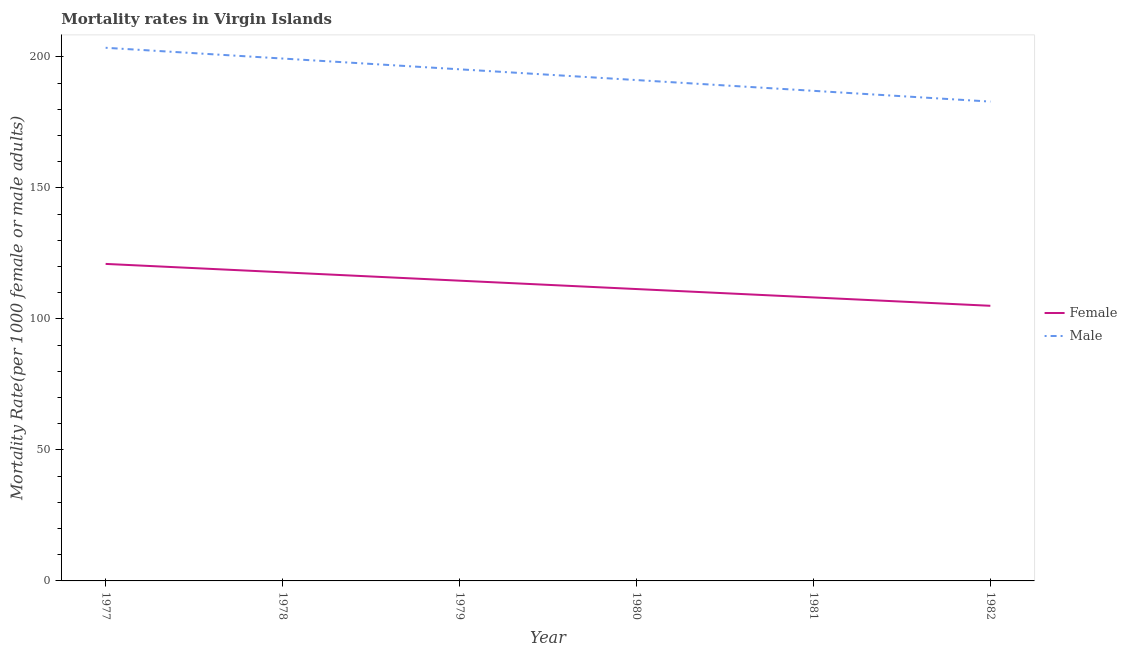Does the line corresponding to male mortality rate intersect with the line corresponding to female mortality rate?
Your answer should be compact. No. Is the number of lines equal to the number of legend labels?
Your answer should be very brief. Yes. What is the female mortality rate in 1980?
Your answer should be very brief. 111.38. Across all years, what is the maximum male mortality rate?
Make the answer very short. 203.45. Across all years, what is the minimum male mortality rate?
Provide a succinct answer. 182.92. In which year was the male mortality rate minimum?
Your response must be concise. 1982. What is the total female mortality rate in the graph?
Provide a short and direct response. 677.89. What is the difference between the male mortality rate in 1981 and that in 1982?
Provide a succinct answer. 4.11. What is the difference between the male mortality rate in 1980 and the female mortality rate in 1978?
Make the answer very short. 73.36. What is the average female mortality rate per year?
Provide a short and direct response. 112.98. In the year 1982, what is the difference between the male mortality rate and female mortality rate?
Keep it short and to the point. 77.93. In how many years, is the female mortality rate greater than 160?
Your response must be concise. 0. What is the ratio of the female mortality rate in 1980 to that in 1981?
Your answer should be compact. 1.03. What is the difference between the highest and the second highest female mortality rate?
Offer a very short reply. 3.2. What is the difference between the highest and the lowest female mortality rate?
Make the answer very short. 15.98. In how many years, is the male mortality rate greater than the average male mortality rate taken over all years?
Your response must be concise. 3. Is the sum of the female mortality rate in 1979 and 1981 greater than the maximum male mortality rate across all years?
Offer a terse response. Yes. Does the male mortality rate monotonically increase over the years?
Your response must be concise. No. Is the female mortality rate strictly greater than the male mortality rate over the years?
Offer a very short reply. No. How many lines are there?
Offer a terse response. 2. Does the graph contain any zero values?
Ensure brevity in your answer.  No. Does the graph contain grids?
Your response must be concise. No. Where does the legend appear in the graph?
Make the answer very short. Center right. What is the title of the graph?
Your response must be concise. Mortality rates in Virgin Islands. What is the label or title of the Y-axis?
Your answer should be very brief. Mortality Rate(per 1000 female or male adults). What is the Mortality Rate(per 1000 female or male adults) of Female in 1977?
Ensure brevity in your answer.  120.97. What is the Mortality Rate(per 1000 female or male adults) in Male in 1977?
Give a very brief answer. 203.45. What is the Mortality Rate(per 1000 female or male adults) of Female in 1978?
Make the answer very short. 117.78. What is the Mortality Rate(per 1000 female or male adults) of Male in 1978?
Keep it short and to the point. 199.35. What is the Mortality Rate(per 1000 female or male adults) of Female in 1979?
Make the answer very short. 114.58. What is the Mortality Rate(per 1000 female or male adults) of Male in 1979?
Offer a very short reply. 195.24. What is the Mortality Rate(per 1000 female or male adults) in Female in 1980?
Offer a very short reply. 111.38. What is the Mortality Rate(per 1000 female or male adults) of Male in 1980?
Ensure brevity in your answer.  191.13. What is the Mortality Rate(per 1000 female or male adults) of Female in 1981?
Ensure brevity in your answer.  108.19. What is the Mortality Rate(per 1000 female or male adults) of Male in 1981?
Offer a terse response. 187.03. What is the Mortality Rate(per 1000 female or male adults) of Female in 1982?
Your response must be concise. 104.99. What is the Mortality Rate(per 1000 female or male adults) of Male in 1982?
Keep it short and to the point. 182.92. Across all years, what is the maximum Mortality Rate(per 1000 female or male adults) in Female?
Keep it short and to the point. 120.97. Across all years, what is the maximum Mortality Rate(per 1000 female or male adults) of Male?
Offer a terse response. 203.45. Across all years, what is the minimum Mortality Rate(per 1000 female or male adults) of Female?
Provide a succinct answer. 104.99. Across all years, what is the minimum Mortality Rate(per 1000 female or male adults) in Male?
Your answer should be compact. 182.92. What is the total Mortality Rate(per 1000 female or male adults) of Female in the graph?
Provide a short and direct response. 677.89. What is the total Mortality Rate(per 1000 female or male adults) in Male in the graph?
Ensure brevity in your answer.  1159.12. What is the difference between the Mortality Rate(per 1000 female or male adults) in Female in 1977 and that in 1978?
Keep it short and to the point. 3.2. What is the difference between the Mortality Rate(per 1000 female or male adults) of Male in 1977 and that in 1978?
Your answer should be compact. 4.11. What is the difference between the Mortality Rate(per 1000 female or male adults) of Female in 1977 and that in 1979?
Your answer should be compact. 6.39. What is the difference between the Mortality Rate(per 1000 female or male adults) of Male in 1977 and that in 1979?
Offer a very short reply. 8.21. What is the difference between the Mortality Rate(per 1000 female or male adults) of Female in 1977 and that in 1980?
Make the answer very short. 9.59. What is the difference between the Mortality Rate(per 1000 female or male adults) of Male in 1977 and that in 1980?
Offer a very short reply. 12.32. What is the difference between the Mortality Rate(per 1000 female or male adults) in Female in 1977 and that in 1981?
Provide a succinct answer. 12.79. What is the difference between the Mortality Rate(per 1000 female or male adults) in Male in 1977 and that in 1981?
Offer a terse response. 16.43. What is the difference between the Mortality Rate(per 1000 female or male adults) in Female in 1977 and that in 1982?
Ensure brevity in your answer.  15.98. What is the difference between the Mortality Rate(per 1000 female or male adults) in Male in 1977 and that in 1982?
Your response must be concise. 20.54. What is the difference between the Mortality Rate(per 1000 female or male adults) in Female in 1978 and that in 1979?
Your answer should be compact. 3.2. What is the difference between the Mortality Rate(per 1000 female or male adults) in Male in 1978 and that in 1979?
Provide a succinct answer. 4.11. What is the difference between the Mortality Rate(per 1000 female or male adults) of Female in 1978 and that in 1980?
Your response must be concise. 6.39. What is the difference between the Mortality Rate(per 1000 female or male adults) of Male in 1978 and that in 1980?
Your answer should be compact. 8.21. What is the difference between the Mortality Rate(per 1000 female or male adults) in Female in 1978 and that in 1981?
Offer a terse response. 9.59. What is the difference between the Mortality Rate(per 1000 female or male adults) of Male in 1978 and that in 1981?
Offer a very short reply. 12.32. What is the difference between the Mortality Rate(per 1000 female or male adults) of Female in 1978 and that in 1982?
Make the answer very short. 12.79. What is the difference between the Mortality Rate(per 1000 female or male adults) of Male in 1978 and that in 1982?
Provide a succinct answer. 16.43. What is the difference between the Mortality Rate(per 1000 female or male adults) in Female in 1979 and that in 1980?
Provide a succinct answer. 3.2. What is the difference between the Mortality Rate(per 1000 female or male adults) in Male in 1979 and that in 1980?
Your answer should be compact. 4.11. What is the difference between the Mortality Rate(per 1000 female or male adults) in Female in 1979 and that in 1981?
Provide a short and direct response. 6.39. What is the difference between the Mortality Rate(per 1000 female or male adults) of Male in 1979 and that in 1981?
Keep it short and to the point. 8.21. What is the difference between the Mortality Rate(per 1000 female or male adults) in Female in 1979 and that in 1982?
Keep it short and to the point. 9.59. What is the difference between the Mortality Rate(per 1000 female or male adults) in Male in 1979 and that in 1982?
Your answer should be very brief. 12.32. What is the difference between the Mortality Rate(per 1000 female or male adults) of Female in 1980 and that in 1981?
Offer a very short reply. 3.2. What is the difference between the Mortality Rate(per 1000 female or male adults) in Male in 1980 and that in 1981?
Provide a succinct answer. 4.11. What is the difference between the Mortality Rate(per 1000 female or male adults) in Female in 1980 and that in 1982?
Make the answer very short. 6.39. What is the difference between the Mortality Rate(per 1000 female or male adults) of Male in 1980 and that in 1982?
Give a very brief answer. 8.21. What is the difference between the Mortality Rate(per 1000 female or male adults) in Female in 1981 and that in 1982?
Provide a succinct answer. 3.2. What is the difference between the Mortality Rate(per 1000 female or male adults) of Male in 1981 and that in 1982?
Your answer should be very brief. 4.11. What is the difference between the Mortality Rate(per 1000 female or male adults) in Female in 1977 and the Mortality Rate(per 1000 female or male adults) in Male in 1978?
Give a very brief answer. -78.37. What is the difference between the Mortality Rate(per 1000 female or male adults) of Female in 1977 and the Mortality Rate(per 1000 female or male adults) of Male in 1979?
Keep it short and to the point. -74.27. What is the difference between the Mortality Rate(per 1000 female or male adults) in Female in 1977 and the Mortality Rate(per 1000 female or male adults) in Male in 1980?
Make the answer very short. -70.16. What is the difference between the Mortality Rate(per 1000 female or male adults) in Female in 1977 and the Mortality Rate(per 1000 female or male adults) in Male in 1981?
Give a very brief answer. -66.05. What is the difference between the Mortality Rate(per 1000 female or male adults) in Female in 1977 and the Mortality Rate(per 1000 female or male adults) in Male in 1982?
Your answer should be very brief. -61.95. What is the difference between the Mortality Rate(per 1000 female or male adults) of Female in 1978 and the Mortality Rate(per 1000 female or male adults) of Male in 1979?
Give a very brief answer. -77.46. What is the difference between the Mortality Rate(per 1000 female or male adults) in Female in 1978 and the Mortality Rate(per 1000 female or male adults) in Male in 1980?
Your answer should be compact. -73.36. What is the difference between the Mortality Rate(per 1000 female or male adults) of Female in 1978 and the Mortality Rate(per 1000 female or male adults) of Male in 1981?
Provide a succinct answer. -69.25. What is the difference between the Mortality Rate(per 1000 female or male adults) in Female in 1978 and the Mortality Rate(per 1000 female or male adults) in Male in 1982?
Offer a terse response. -65.14. What is the difference between the Mortality Rate(per 1000 female or male adults) in Female in 1979 and the Mortality Rate(per 1000 female or male adults) in Male in 1980?
Keep it short and to the point. -76.55. What is the difference between the Mortality Rate(per 1000 female or male adults) of Female in 1979 and the Mortality Rate(per 1000 female or male adults) of Male in 1981?
Offer a very short reply. -72.45. What is the difference between the Mortality Rate(per 1000 female or male adults) of Female in 1979 and the Mortality Rate(per 1000 female or male adults) of Male in 1982?
Your answer should be compact. -68.34. What is the difference between the Mortality Rate(per 1000 female or male adults) in Female in 1980 and the Mortality Rate(per 1000 female or male adults) in Male in 1981?
Keep it short and to the point. -75.64. What is the difference between the Mortality Rate(per 1000 female or male adults) of Female in 1980 and the Mortality Rate(per 1000 female or male adults) of Male in 1982?
Give a very brief answer. -71.54. What is the difference between the Mortality Rate(per 1000 female or male adults) in Female in 1981 and the Mortality Rate(per 1000 female or male adults) in Male in 1982?
Provide a succinct answer. -74.73. What is the average Mortality Rate(per 1000 female or male adults) of Female per year?
Your answer should be very brief. 112.98. What is the average Mortality Rate(per 1000 female or male adults) of Male per year?
Offer a terse response. 193.19. In the year 1977, what is the difference between the Mortality Rate(per 1000 female or male adults) in Female and Mortality Rate(per 1000 female or male adults) in Male?
Keep it short and to the point. -82.48. In the year 1978, what is the difference between the Mortality Rate(per 1000 female or male adults) in Female and Mortality Rate(per 1000 female or male adults) in Male?
Provide a short and direct response. -81.57. In the year 1979, what is the difference between the Mortality Rate(per 1000 female or male adults) of Female and Mortality Rate(per 1000 female or male adults) of Male?
Offer a terse response. -80.66. In the year 1980, what is the difference between the Mortality Rate(per 1000 female or male adults) in Female and Mortality Rate(per 1000 female or male adults) in Male?
Ensure brevity in your answer.  -79.75. In the year 1981, what is the difference between the Mortality Rate(per 1000 female or male adults) in Female and Mortality Rate(per 1000 female or male adults) in Male?
Provide a short and direct response. -78.84. In the year 1982, what is the difference between the Mortality Rate(per 1000 female or male adults) of Female and Mortality Rate(per 1000 female or male adults) of Male?
Offer a terse response. -77.93. What is the ratio of the Mortality Rate(per 1000 female or male adults) in Female in 1977 to that in 1978?
Make the answer very short. 1.03. What is the ratio of the Mortality Rate(per 1000 female or male adults) of Male in 1977 to that in 1978?
Provide a short and direct response. 1.02. What is the ratio of the Mortality Rate(per 1000 female or male adults) in Female in 1977 to that in 1979?
Provide a succinct answer. 1.06. What is the ratio of the Mortality Rate(per 1000 female or male adults) of Male in 1977 to that in 1979?
Give a very brief answer. 1.04. What is the ratio of the Mortality Rate(per 1000 female or male adults) of Female in 1977 to that in 1980?
Your answer should be very brief. 1.09. What is the ratio of the Mortality Rate(per 1000 female or male adults) of Male in 1977 to that in 1980?
Ensure brevity in your answer.  1.06. What is the ratio of the Mortality Rate(per 1000 female or male adults) of Female in 1977 to that in 1981?
Offer a very short reply. 1.12. What is the ratio of the Mortality Rate(per 1000 female or male adults) in Male in 1977 to that in 1981?
Offer a very short reply. 1.09. What is the ratio of the Mortality Rate(per 1000 female or male adults) of Female in 1977 to that in 1982?
Provide a short and direct response. 1.15. What is the ratio of the Mortality Rate(per 1000 female or male adults) in Male in 1977 to that in 1982?
Make the answer very short. 1.11. What is the ratio of the Mortality Rate(per 1000 female or male adults) of Female in 1978 to that in 1979?
Give a very brief answer. 1.03. What is the ratio of the Mortality Rate(per 1000 female or male adults) in Male in 1978 to that in 1979?
Keep it short and to the point. 1.02. What is the ratio of the Mortality Rate(per 1000 female or male adults) of Female in 1978 to that in 1980?
Make the answer very short. 1.06. What is the ratio of the Mortality Rate(per 1000 female or male adults) in Male in 1978 to that in 1980?
Provide a short and direct response. 1.04. What is the ratio of the Mortality Rate(per 1000 female or male adults) in Female in 1978 to that in 1981?
Your response must be concise. 1.09. What is the ratio of the Mortality Rate(per 1000 female or male adults) in Male in 1978 to that in 1981?
Provide a short and direct response. 1.07. What is the ratio of the Mortality Rate(per 1000 female or male adults) of Female in 1978 to that in 1982?
Your response must be concise. 1.12. What is the ratio of the Mortality Rate(per 1000 female or male adults) in Male in 1978 to that in 1982?
Give a very brief answer. 1.09. What is the ratio of the Mortality Rate(per 1000 female or male adults) in Female in 1979 to that in 1980?
Your answer should be very brief. 1.03. What is the ratio of the Mortality Rate(per 1000 female or male adults) in Male in 1979 to that in 1980?
Your response must be concise. 1.02. What is the ratio of the Mortality Rate(per 1000 female or male adults) in Female in 1979 to that in 1981?
Give a very brief answer. 1.06. What is the ratio of the Mortality Rate(per 1000 female or male adults) in Male in 1979 to that in 1981?
Ensure brevity in your answer.  1.04. What is the ratio of the Mortality Rate(per 1000 female or male adults) of Female in 1979 to that in 1982?
Keep it short and to the point. 1.09. What is the ratio of the Mortality Rate(per 1000 female or male adults) in Male in 1979 to that in 1982?
Provide a short and direct response. 1.07. What is the ratio of the Mortality Rate(per 1000 female or male adults) of Female in 1980 to that in 1981?
Ensure brevity in your answer.  1.03. What is the ratio of the Mortality Rate(per 1000 female or male adults) of Female in 1980 to that in 1982?
Ensure brevity in your answer.  1.06. What is the ratio of the Mortality Rate(per 1000 female or male adults) in Male in 1980 to that in 1982?
Ensure brevity in your answer.  1.04. What is the ratio of the Mortality Rate(per 1000 female or male adults) of Female in 1981 to that in 1982?
Offer a terse response. 1.03. What is the ratio of the Mortality Rate(per 1000 female or male adults) in Male in 1981 to that in 1982?
Your answer should be compact. 1.02. What is the difference between the highest and the second highest Mortality Rate(per 1000 female or male adults) of Female?
Provide a short and direct response. 3.2. What is the difference between the highest and the second highest Mortality Rate(per 1000 female or male adults) of Male?
Provide a short and direct response. 4.11. What is the difference between the highest and the lowest Mortality Rate(per 1000 female or male adults) of Female?
Make the answer very short. 15.98. What is the difference between the highest and the lowest Mortality Rate(per 1000 female or male adults) of Male?
Provide a succinct answer. 20.54. 